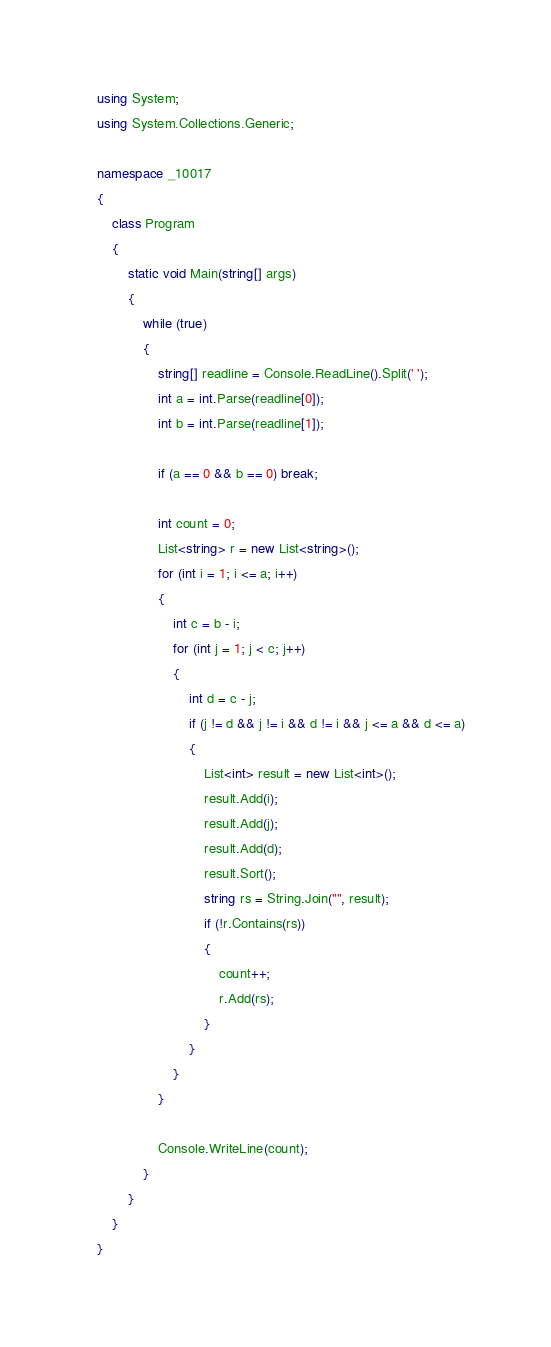Convert code to text. <code><loc_0><loc_0><loc_500><loc_500><_C#_>using System;
using System.Collections.Generic;

namespace _10017
{
    class Program
    {
        static void Main(string[] args)
        {
            while (true)
            {
                string[] readline = Console.ReadLine().Split(' ');
                int a = int.Parse(readline[0]);
                int b = int.Parse(readline[1]);

                if (a == 0 && b == 0) break;

                int count = 0;
                List<string> r = new List<string>();
                for (int i = 1; i <= a; i++)
                {
                    int c = b - i;
                    for (int j = 1; j < c; j++)
                    {
                        int d = c - j;
                        if (j != d && j != i && d != i && j <= a && d <= a)
                        {
                            List<int> result = new List<int>();
                            result.Add(i);
                            result.Add(j);
                            result.Add(d);
                            result.Sort();
                            string rs = String.Join("", result);
                            if (!r.Contains(rs))
                            {
                                count++;
                                r.Add(rs);
                            }
                        }
                    }
                }

                Console.WriteLine(count);
            }
        }
    }
}</code> 